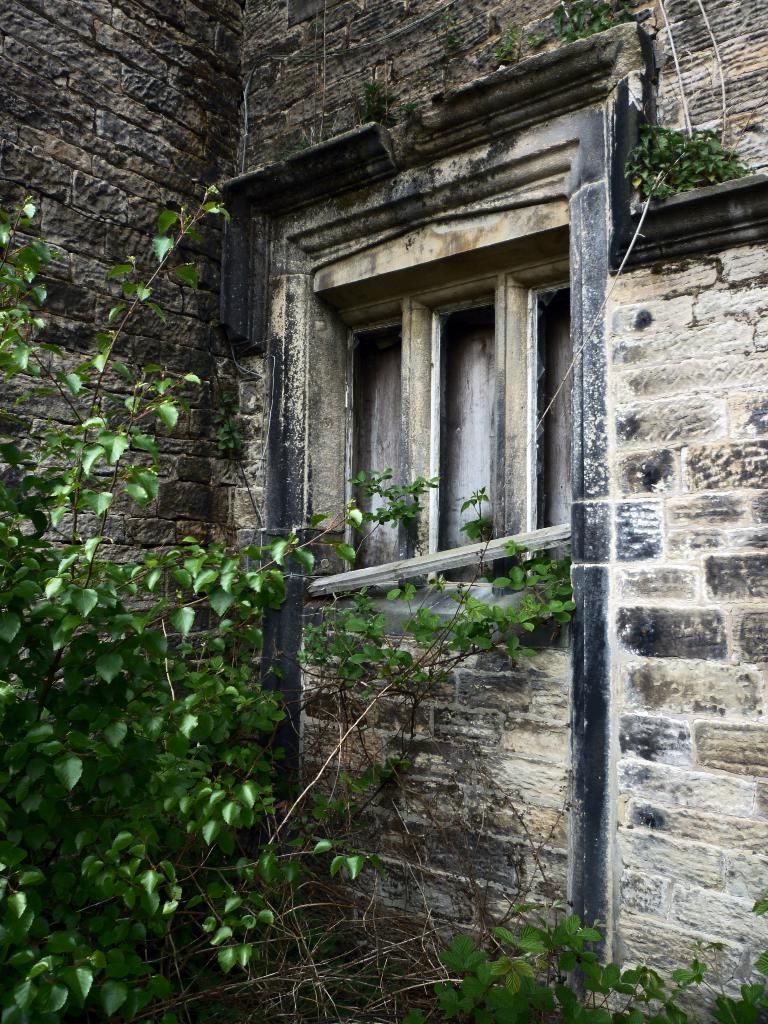What type of structure is present in the image? There is a building in the image. What material is the building made of? The building is made up of stones. Are there any openings in the building? Yes, there is a window in the building. What can be seen in the image besides the building? Leaves are visible in the image. What type of wax is being used by the laborer in the image? There is no laborer or wax present in the image. What is the quill being used for in the image? There is no quill present in the image. 